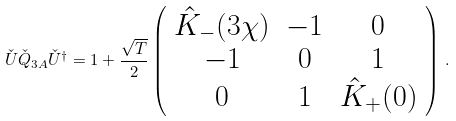<formula> <loc_0><loc_0><loc_500><loc_500>\check { U } \check { Q } _ { 3 A } \check { U } ^ { \dagger } = 1 + \frac { \sqrt { T } } { 2 } \left ( \begin{array} [ c ] { c c c } \hat { K } _ { - } ( 3 \chi ) & - 1 & 0 \\ - 1 & 0 & 1 \\ 0 & 1 & \hat { K } _ { + } ( 0 ) \end{array} \right ) \, .</formula> 